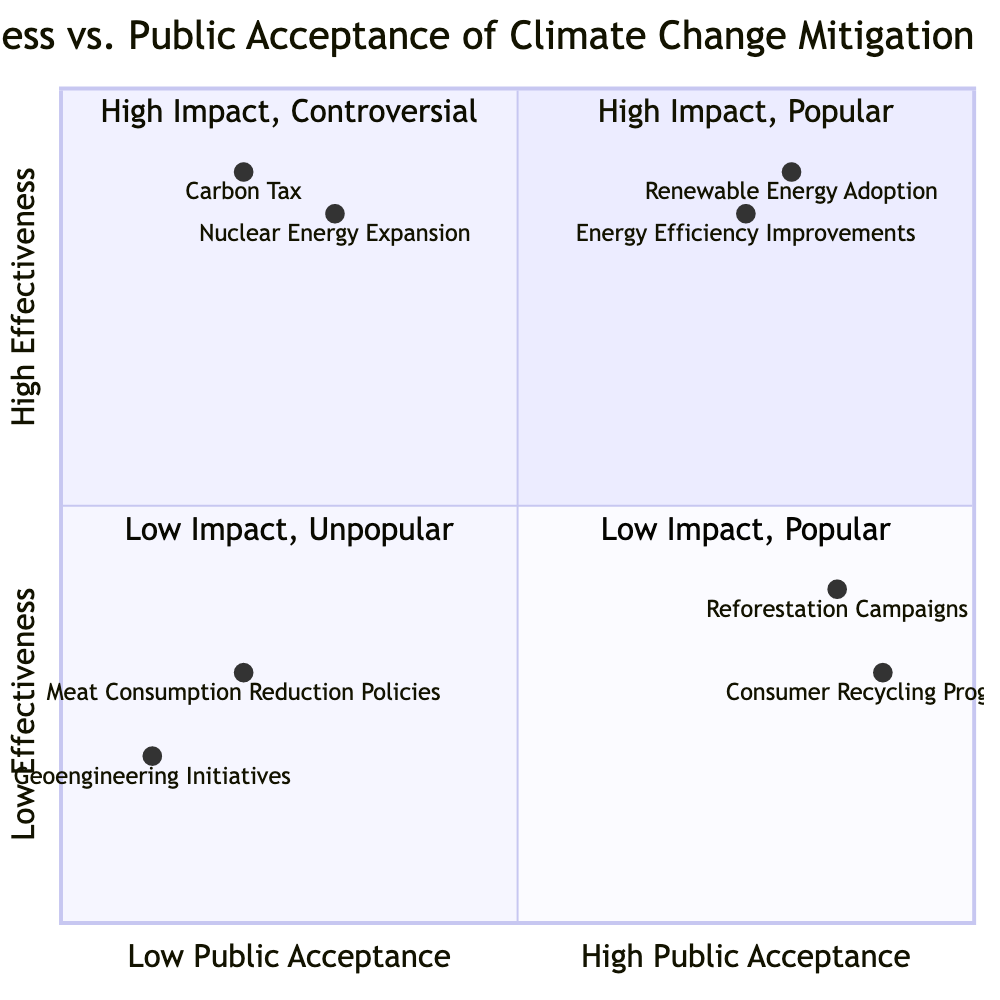What are the two strategies located in the "High Effectiveness - High Public Acceptance" quadrant? The quadrant labeled "High Effectiveness - High Public Acceptance" contains two strategies: "Renewable Energy Adoption" and "Energy Efficiency Improvements."
Answer: Renewable Energy Adoption, Energy Efficiency Improvements Which strategy has the lowest effectiveness score? Among the strategies plotted, the one with the lowest effectiveness score is "Geoengineering Initiatives," which has a score of 0.1.
Answer: Geoengineering Initiatives How many strategies are categorized as "Low Effectiveness - Low Public Acceptance"? There are two strategies in the "Low Effectiveness - Low Public Acceptance" quadrant: "Geoengineering Initiatives" and "Meat Consumption Reduction Policies."
Answer: 2 What is the effectiveness score of "Carbon Tax"? The effectiveness score of "Carbon Tax" is 0.2, as plotted in the quadrant chart.
Answer: 0.2 Which strategy has high public acceptance but low effectiveness? The strategy that has high public acceptance (0.9) but low effectiveness (0.3) is "Consumer Recycling Programs."
Answer: Consumer Recycling Programs Which quadrant contains the "Nuclear Energy Expansion" strategy? "Nuclear Energy Expansion" is located in the "High Effectiveness - Low Public Acceptance" quadrant, as indicated by its effectiveness and public acceptance scores.
Answer: High Effectiveness - Low Public Acceptance What is the public acceptance score of "Reforestation Campaigns"? The public acceptance score for "Reforestation Campaigns" is 0.4, as noted in the quadrant chart.
Answer: 0.4 Which strategy is both effective and popular? The strategies that are both effective and popular (high effectiveness and high public acceptance) are "Renewable Energy Adoption" and "Energy Efficiency Improvements."
Answer: Renewable Energy Adoption, Energy Efficiency Improvements Which quadrant would contain strategies that are effective but not widely accepted? The strategies that are effective (high effectiveness) but not widely accepted fall into the "High Effectiveness - Low Public Acceptance" quadrant, where "Carbon Tax" and "Nuclear Energy Expansion" are located.
Answer: High Effectiveness - Low Public Acceptance 